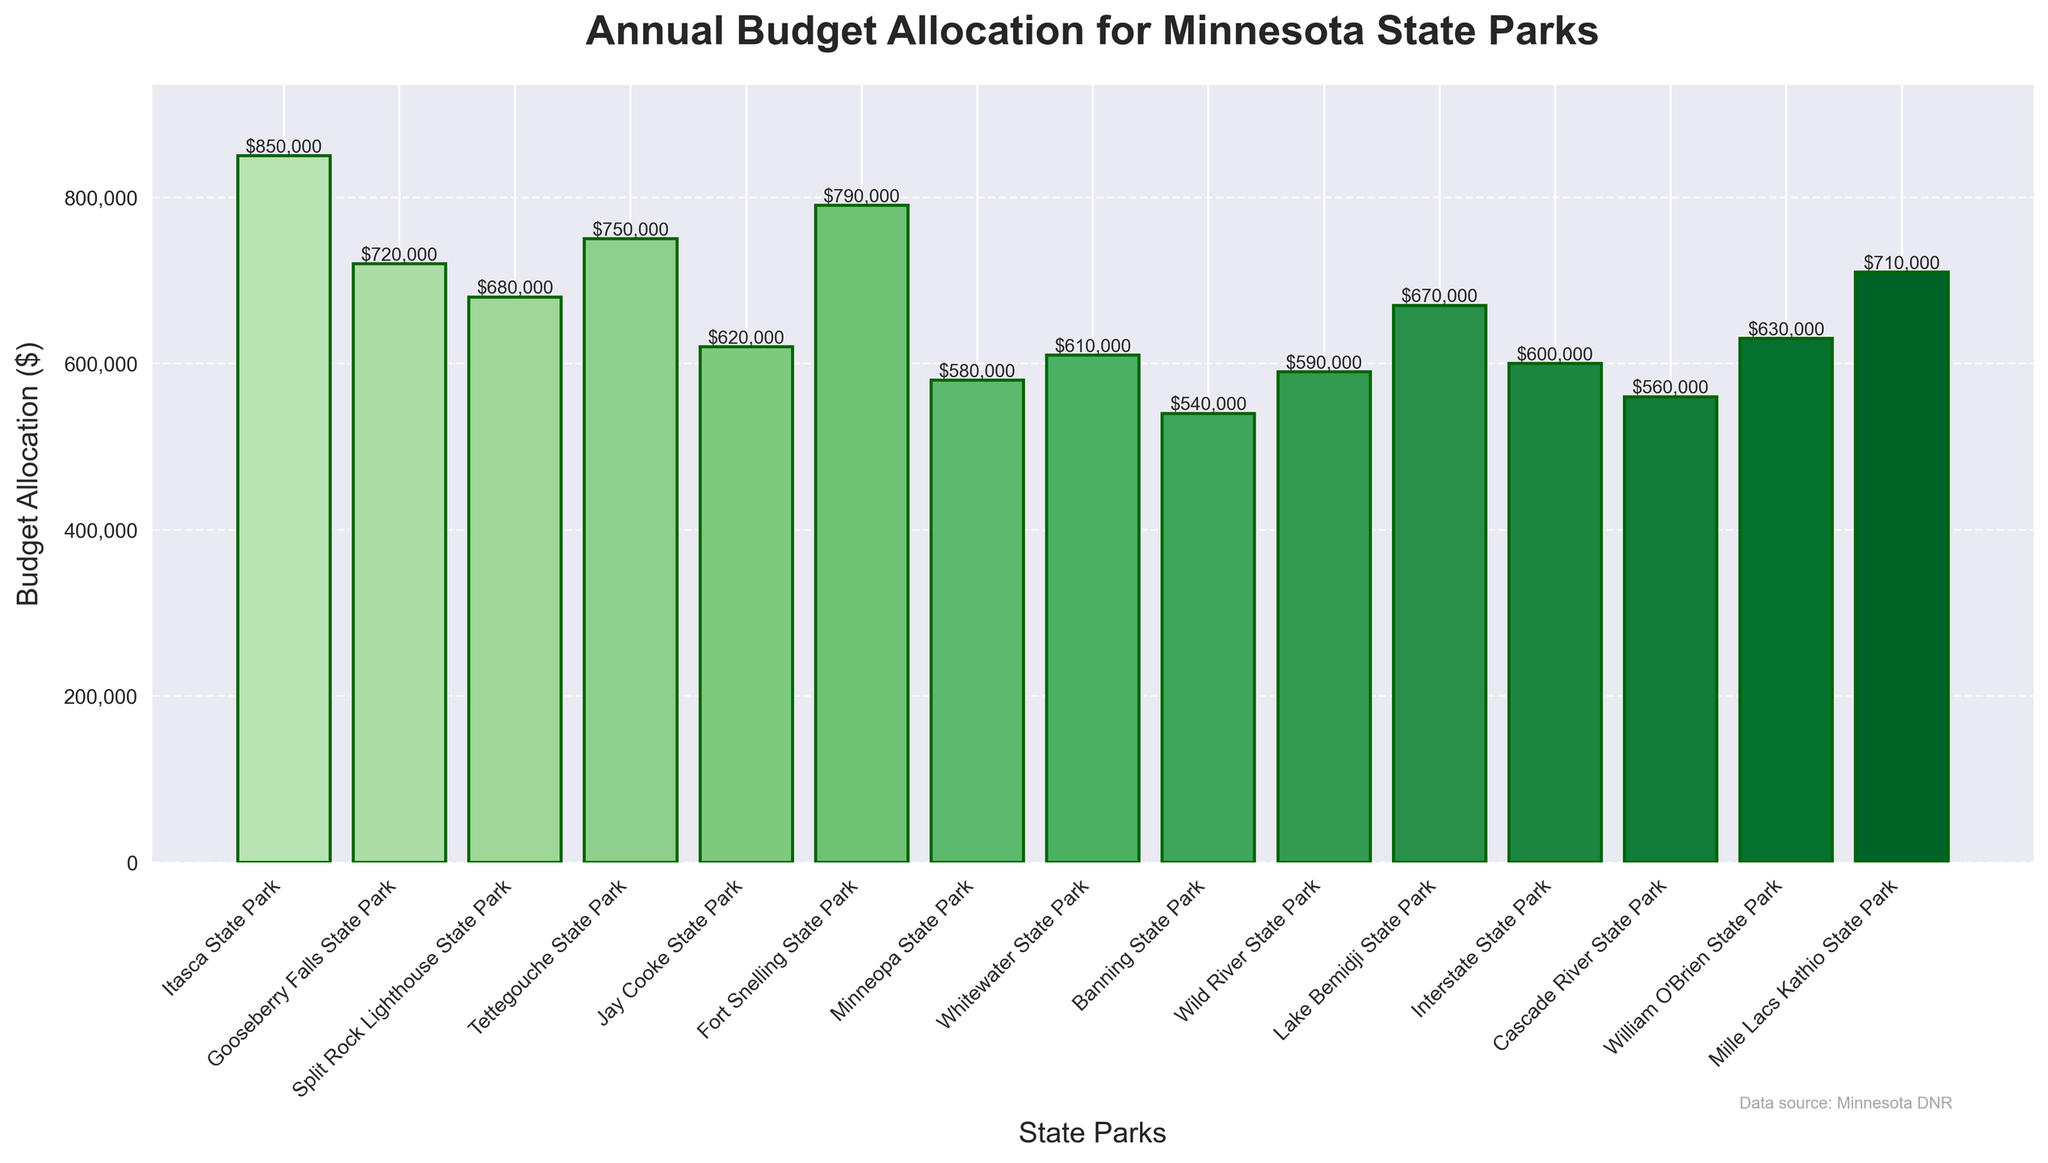What is the annual budget allocation for Itasca State Park? The height of the bar representing Itasca State Park on the bar chart indicates its budget allocation. By referring to the y-axis and the annotation on the bar, we can see that Itasca State Park has an annual budget allocation of $850,000.
Answer: $850,000 Which state park has the lowest budget allocation? To find the state park with the lowest budget allocation, we need to identify the shortest bar on the chart. The shortest bar is for Banning State Park, with a budget allocation of $540,000.
Answer: Banning State Park What is the difference in budget allocation between Gooseberry Falls State Park and Minneopa State Park? First, note the budget allocations: Gooseberry Falls State Park ($720,000) and Minneopa State Park ($580,000). The difference is calculated as $720,000 - $580,000 = $140,000.
Answer: $140,000 Which state park has a budget allocation of more than $700,000 but less than $800,000? We need to identify the bars that fall within the $700,000 to $800,000 range. Split Rock Lighthouse State Park ($680,000) and Mille Lacs Kathio State Park ($710,000) fit this criterion.
Answer: Mille Lacs Kathio State Park What is the sum of the budgets for Tettegouche State Park and Fort Snelling State Park? First, note the budget allocations: Tettegouche State Park ($750,000) and Fort Snelling State Park ($790,000). The sum is calculated as $750,000 + $790,000 = $1,540,000.
Answer: $1,540,000 By how much does the budget allocation for Interstate State Park exceed that of Cascade River State Park? First, note the budget allocations: Interstate State Park ($600,000) and Cascade River State Park ($560,000). The difference is calculated as $600,000 - $560,000 = $40,000.
Answer: $40,000 Which park has a higher budget allocation: William O'Brien State Park or Whitewater State Park? Referring to the bars for both parks, William O'Brien State Park has a budget allocation of $630,000, and Whitewater State Park has a budget allocation of $610,000. Therefore, William O'Brien State Park has a higher budget.
Answer: William O'Brien State Park What is the average budget allocation for the first five state parks in the chart? First, list the first five budget allocations: Itasca State Park ($850,000), Gooseberry Falls State Park ($720,000), Split Rock Lighthouse State Park ($680,000), Tettegouche State Park ($750,000), and Jay Cooke State Park ($620,000). Sum them: $850,000 + $720,000 + $680,000 + $750,000 + $620,000 = $3,620,000. Divide by five to find the average: $3,620,000 / 5 = $724,000.
Answer: $724,000 